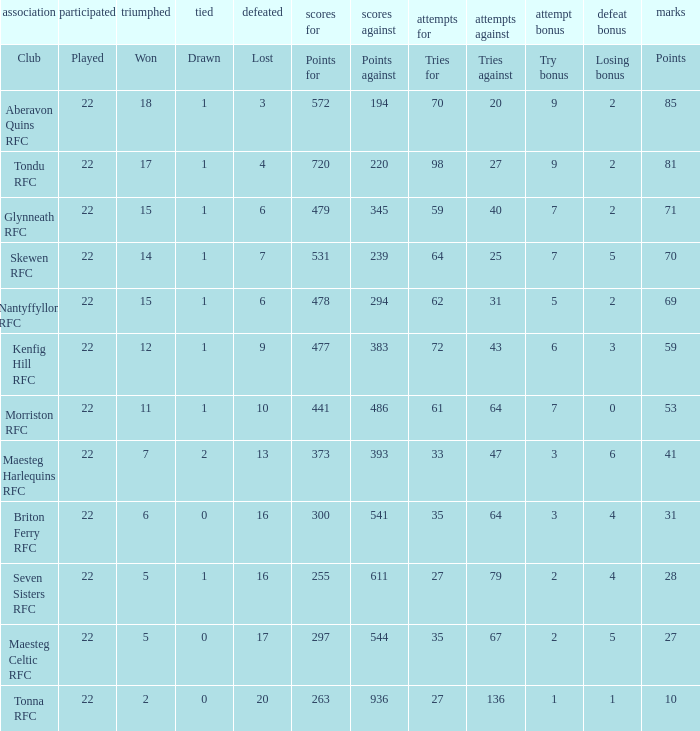What club got 239 points against? Skewen RFC. 